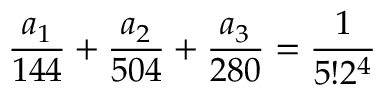Convert formula to latex. <formula><loc_0><loc_0><loc_500><loc_500>\frac { a _ { 1 } } { 1 4 4 } + \frac { a _ { 2 } } { 5 0 4 } + \frac { a _ { 3 } } { 2 8 0 } = \frac { 1 } { 5 ! 2 ^ { 4 } }</formula> 